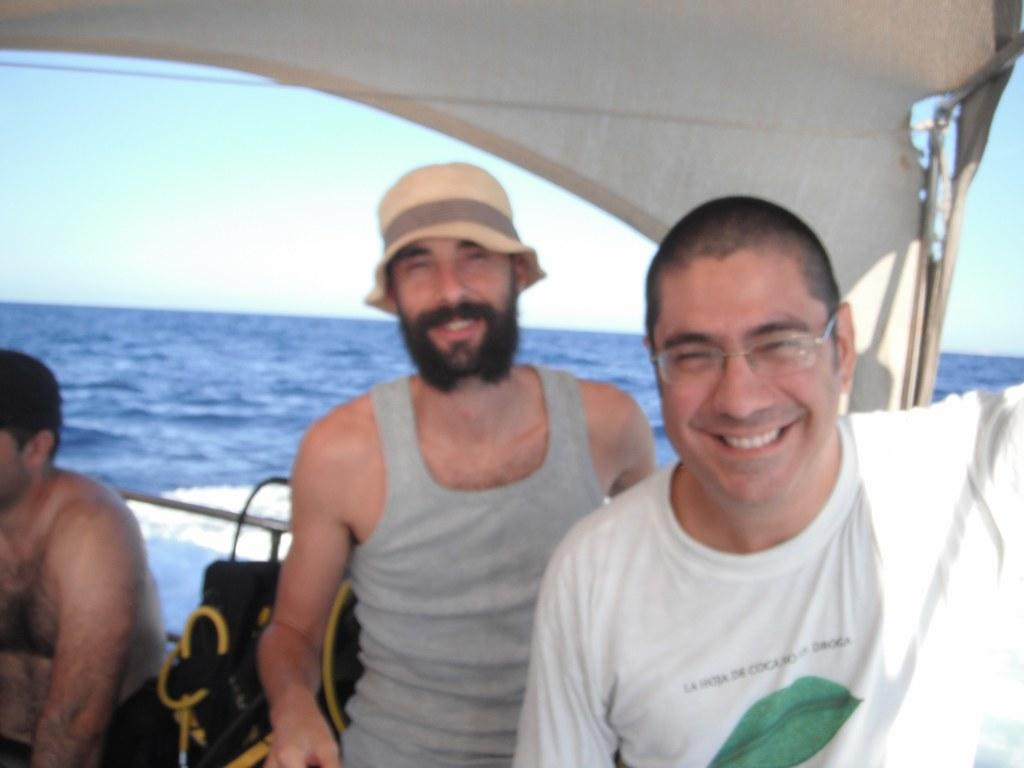What is the main subject of the image? The main subject of the image is a boat. Where is the boat located? The boat is on the water. Are there any people in the boat? Yes, there are persons in the boat. What else can be seen in the boat besides the people? There are other objects in the boat. What can be seen in the background of the image? The sky is visible in the background of the image. What type of lunch is being served in the boat? There is no indication of any lunch being served in the image; it only shows a boat on the water with people and other objects. 